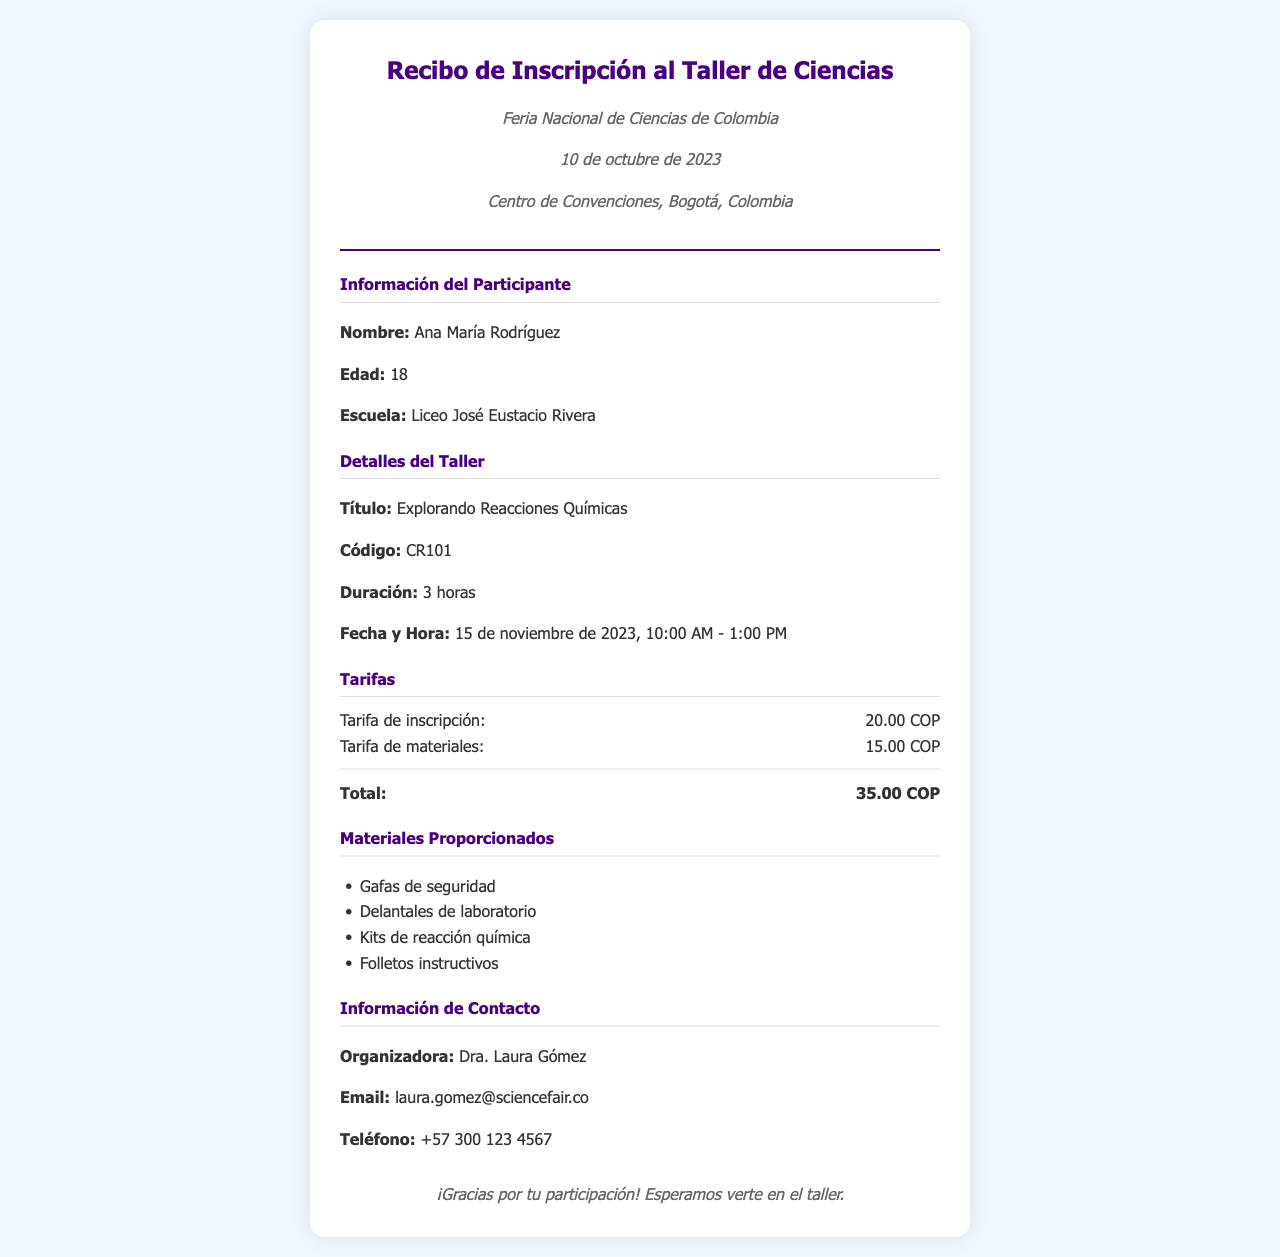¿Qué se titula el taller? El título del taller es "Explorando Reacciones Químicas", que es un detalle específico en la sección de detalles del taller.
Answer: Explorando Reacciones Químicas ¿Cuánto cuesta la tarifa de inscripción? La tarifa de inscripción se menciona en la sección de tarifas, donde se detalla el costo específico.
Answer: 20.00 COP ¿Quién es la organizadora del taller? La organizadora se menciona en la sección de información de contacto, que proporciona el nombre de la persona a cargo del evento.
Answer: Dra. Laura Gómez ¿Cuántas horas dura el taller? La duración del taller se indica en la sección de detalles del taller.
Answer: 3 horas ¿Cuál es la fecha del taller? La fecha del taller se menciona en la sección de detalles, indicando cuándo se llevará a cabo el evento.
Answer: 15 de noviembre de 2023 ¿Qué materiales se proporcionan? Los materiales proporcionados están listados en la sección de materiales proporcionados, que enumera cada uno.
Answer: Gafas de seguridad, Delantales de laboratorio, Kits de reacción química, Folletos instructivos ¿Cuál es el total de la inscripción y materiales? El total se calcula sumando las tarifas de inscripción y materiales en la sección de tarifas.
Answer: 35.00 COP ¿Qué colegio asiste Ana María Rodríguez? La escuela de Ana María Rodríguez se menciona en la sección de información del participante.
Answer: Liceo José Eustacio Rivera 